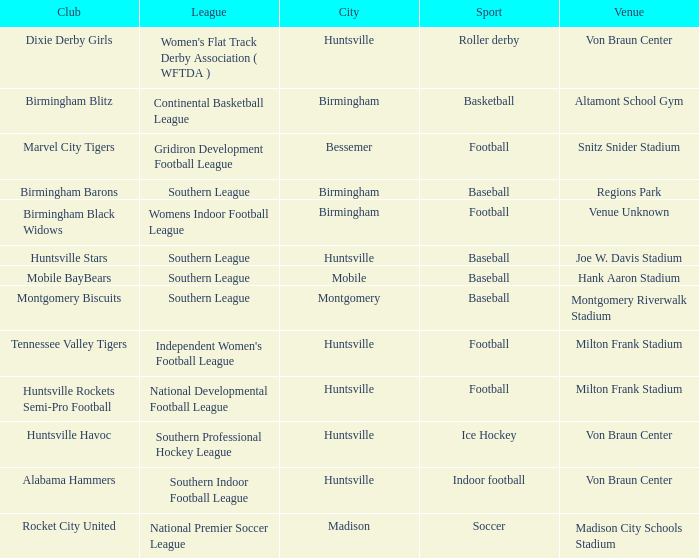Give me the full table as a dictionary. {'header': ['Club', 'League', 'City', 'Sport', 'Venue'], 'rows': [['Dixie Derby Girls', "Women's Flat Track Derby Association ( WFTDA )", 'Huntsville', 'Roller derby', 'Von Braun Center'], ['Birmingham Blitz', 'Continental Basketball League', 'Birmingham', 'Basketball', 'Altamont School Gym'], ['Marvel City Tigers', 'Gridiron Development Football League', 'Bessemer', 'Football', 'Snitz Snider Stadium'], ['Birmingham Barons', 'Southern League', 'Birmingham', 'Baseball', 'Regions Park'], ['Birmingham Black Widows', 'Womens Indoor Football League', 'Birmingham', 'Football', 'Venue Unknown'], ['Huntsville Stars', 'Southern League', 'Huntsville', 'Baseball', 'Joe W. Davis Stadium'], ['Mobile BayBears', 'Southern League', 'Mobile', 'Baseball', 'Hank Aaron Stadium'], ['Montgomery Biscuits', 'Southern League', 'Montgomery', 'Baseball', 'Montgomery Riverwalk Stadium'], ['Tennessee Valley Tigers', "Independent Women's Football League", 'Huntsville', 'Football', 'Milton Frank Stadium'], ['Huntsville Rockets Semi-Pro Football', 'National Developmental Football League', 'Huntsville', 'Football', 'Milton Frank Stadium'], ['Huntsville Havoc', 'Southern Professional Hockey League', 'Huntsville', 'Ice Hockey', 'Von Braun Center'], ['Alabama Hammers', 'Southern Indoor Football League', 'Huntsville', 'Indoor football', 'Von Braun Center'], ['Rocket City United', 'National Premier Soccer League', 'Madison', 'Soccer', 'Madison City Schools Stadium']]} Which venue hosted the Gridiron Development Football League? Snitz Snider Stadium. 